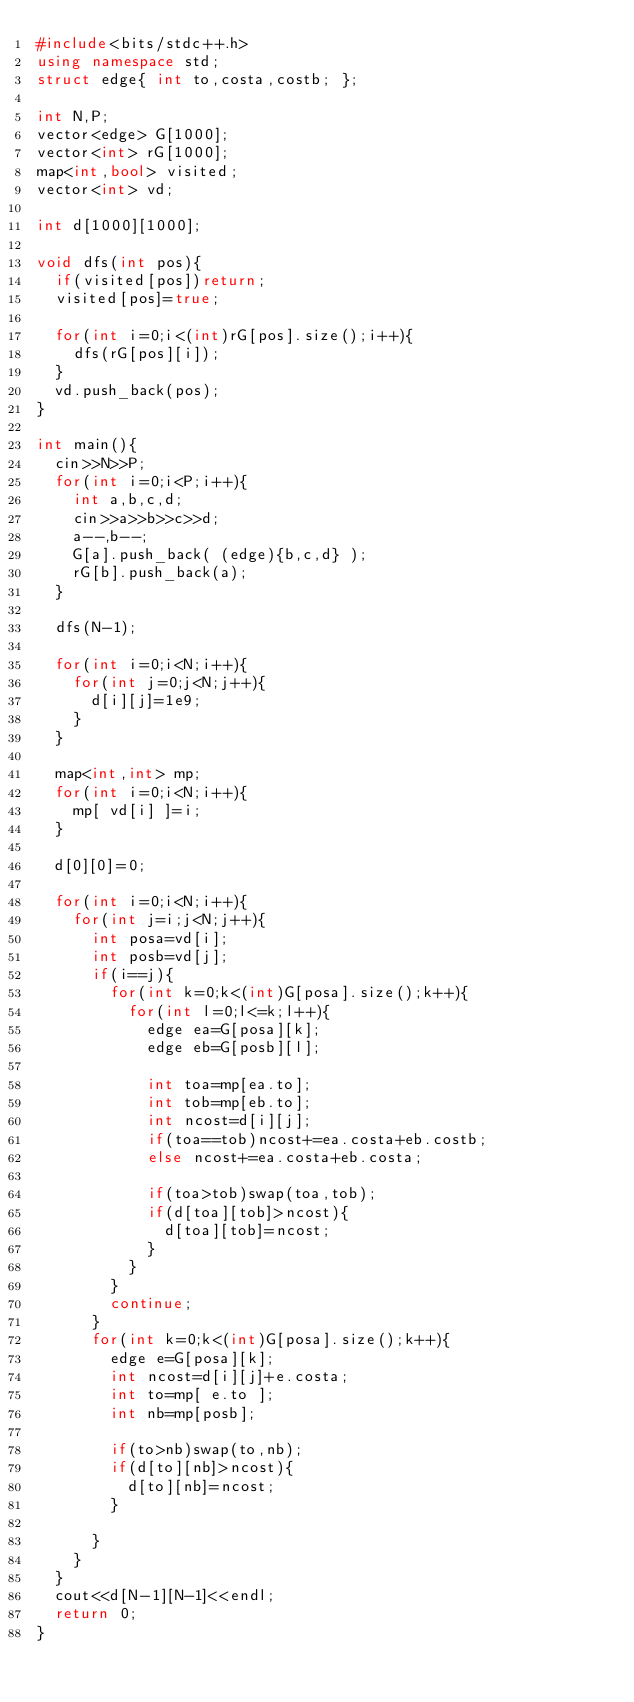Convert code to text. <code><loc_0><loc_0><loc_500><loc_500><_C++_>#include<bits/stdc++.h>
using namespace std;
struct edge{ int to,costa,costb; };

int N,P;
vector<edge> G[1000];
vector<int> rG[1000];
map<int,bool> visited;
vector<int> vd;

int d[1000][1000];

void dfs(int pos){
  if(visited[pos])return;
  visited[pos]=true;
  
  for(int i=0;i<(int)rG[pos].size();i++){
    dfs(rG[pos][i]);
  }
  vd.push_back(pos);
}

int main(){
  cin>>N>>P;
  for(int i=0;i<P;i++){
    int a,b,c,d;
    cin>>a>>b>>c>>d;
    a--,b--;
    G[a].push_back( (edge){b,c,d} );
    rG[b].push_back(a);
  }
  
  dfs(N-1);

  for(int i=0;i<N;i++){
    for(int j=0;j<N;j++){
      d[i][j]=1e9;
    }
  }

  map<int,int> mp;
  for(int i=0;i<N;i++){
    mp[ vd[i] ]=i;
  }
  
  d[0][0]=0;

  for(int i=0;i<N;i++){
    for(int j=i;j<N;j++){
      int posa=vd[i];
      int posb=vd[j];
      if(i==j){
        for(int k=0;k<(int)G[posa].size();k++){
          for(int l=0;l<=k;l++){
            edge ea=G[posa][k];
            edge eb=G[posb][l];
            
            int toa=mp[ea.to];
            int tob=mp[eb.to];
            int ncost=d[i][j];
            if(toa==tob)ncost+=ea.costa+eb.costb;
            else ncost+=ea.costa+eb.costa;

            if(toa>tob)swap(toa,tob);
            if(d[toa][tob]>ncost){
              d[toa][tob]=ncost;            
            }
          }
        }
        continue;
      }
      for(int k=0;k<(int)G[posa].size();k++){
        edge e=G[posa][k];
        int ncost=d[i][j]+e.costa;
        int to=mp[ e.to ];
        int nb=mp[posb];
        
        if(to>nb)swap(to,nb);
        if(d[to][nb]>ncost){
          d[to][nb]=ncost;
        }
        
      }
    }
  }
  cout<<d[N-1][N-1]<<endl;
  return 0;
}</code> 